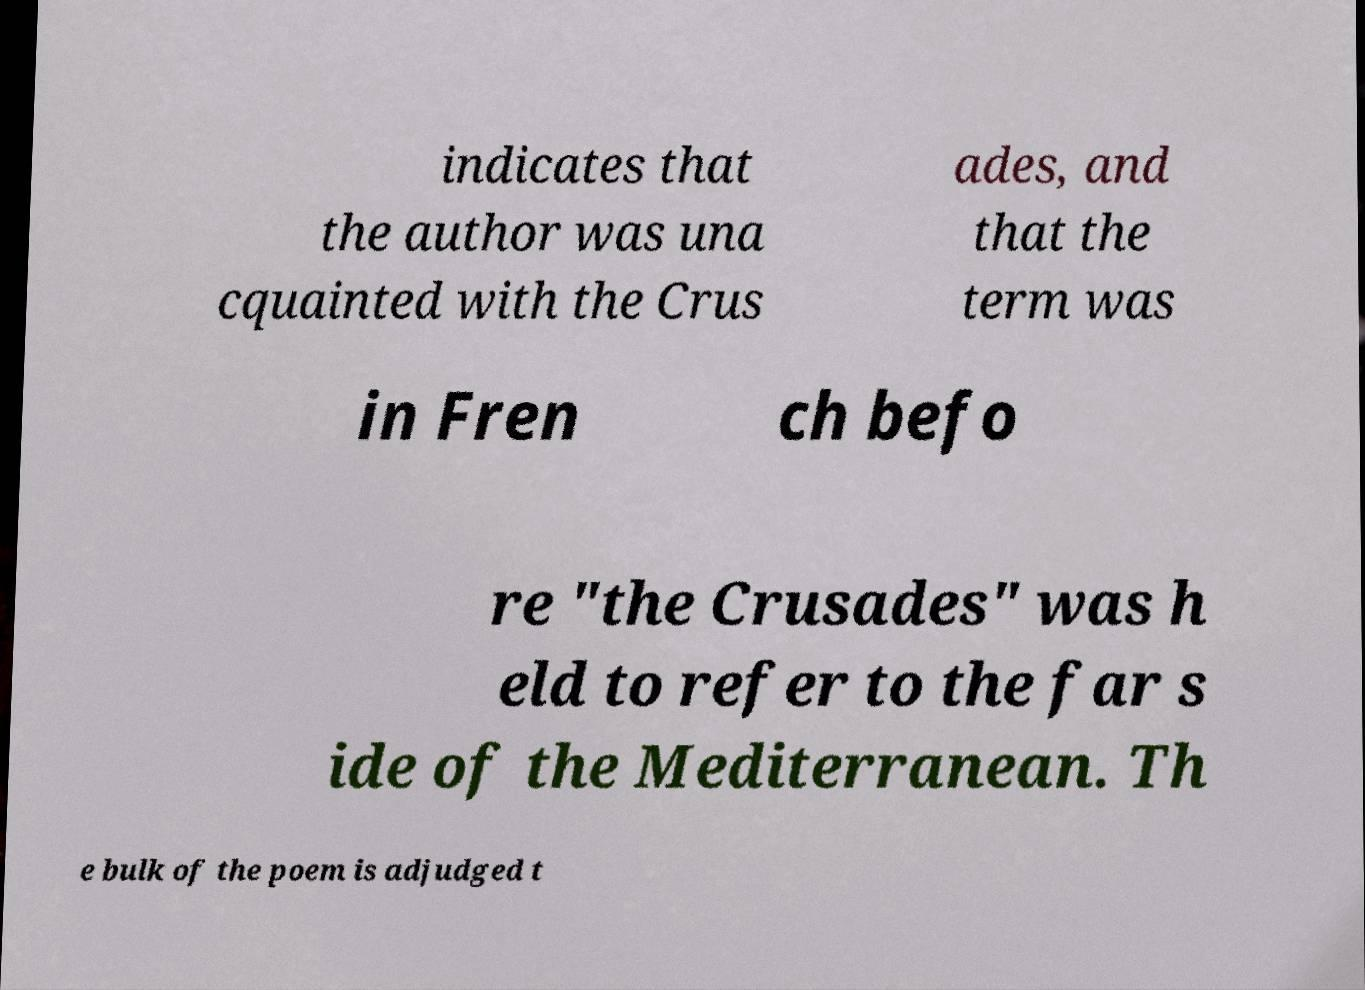Can you accurately transcribe the text from the provided image for me? indicates that the author was una cquainted with the Crus ades, and that the term was in Fren ch befo re "the Crusades" was h eld to refer to the far s ide of the Mediterranean. Th e bulk of the poem is adjudged t 